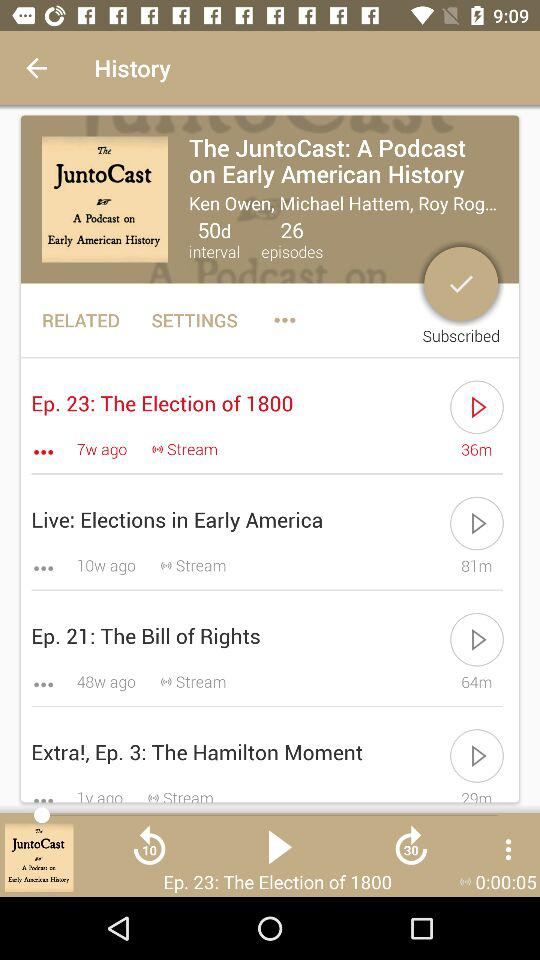What is the total number of episodes? The total number of episodes is 26. 